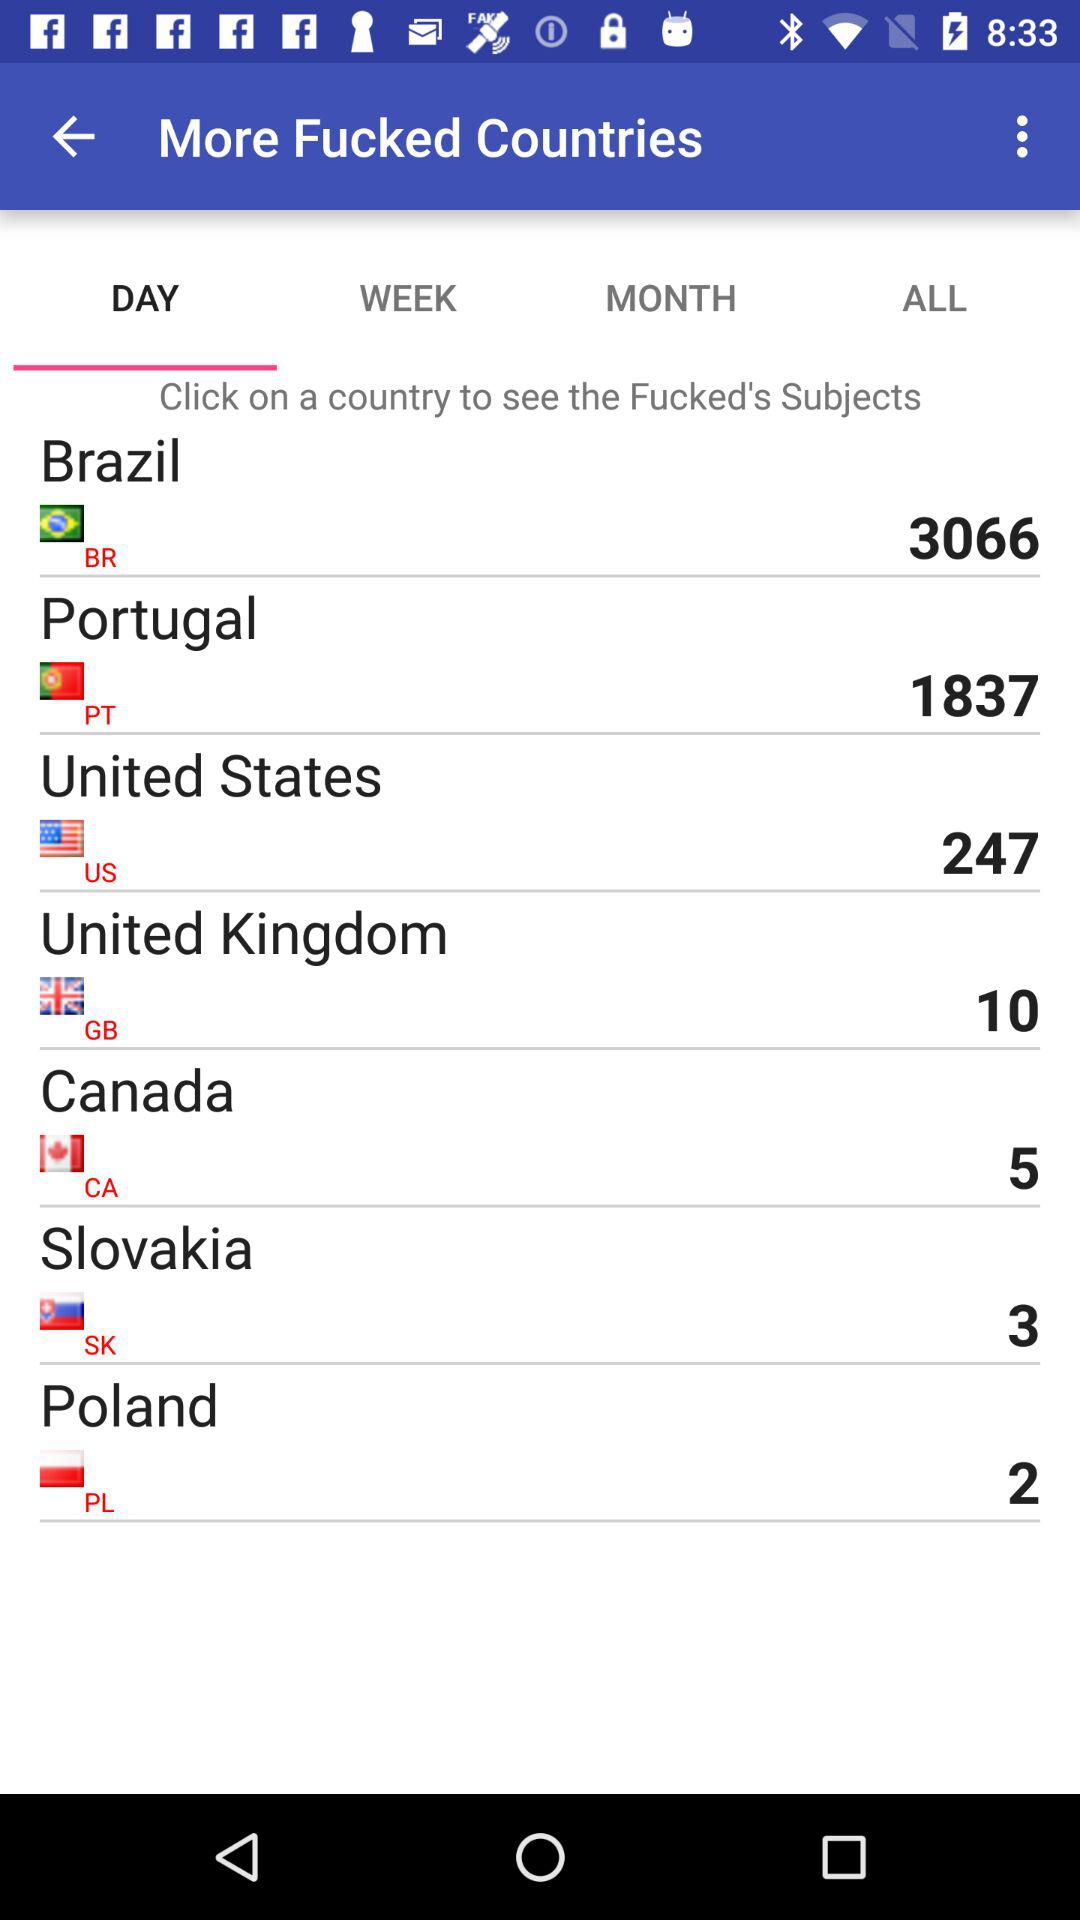What is the count mentioned for Brazil? The mentioned count is 3066. 